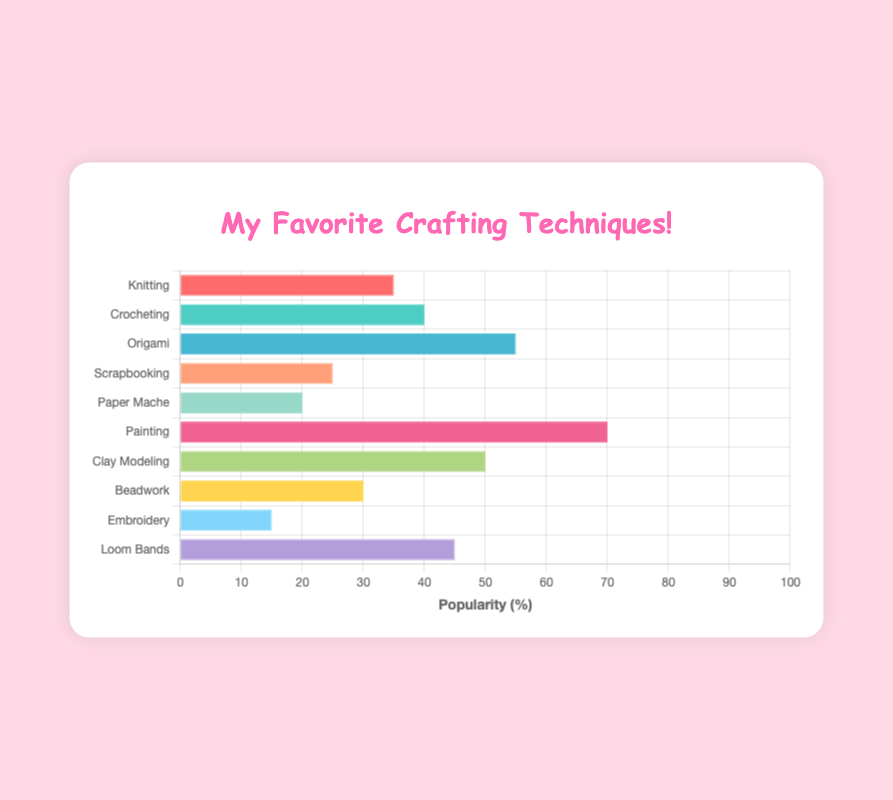Which crafting technique is the most popular among children? To determine the most popular crafting technique, we look for the bar with the highest length. The bar representing "Painting" has the highest value at 70%.
Answer: Painting Which two crafting techniques have equal popularity percentages? We need to find two bars that have the same length. In this case, no two bars have the same exact length, so there are no techniques with equal popularity.
Answer: None What is the difference in popularity between "Origami" and "Beadwork"? First, find the percentages for "Origami" and "Beadwork". Origami is 55%, and Beadwork is 30%. The difference is 55% - 30% = 25%.
Answer: 25% Which crafting technique is less popular, "Knitting" or "Clay Modeling"? Compare the lengths of the bars for "Knitting" and "Clay Modeling". Knitting has 35%, and Clay Modeling has 50%. Since 35% is less than 50%, Knitting is less popular.
Answer: Knitting Arrange the crafting techniques in descending order of popularity. Sort the percentages from highest to lowest: Painting (70%), Origami (55%), Clay Modeling (50%), Loom Bands (45%), Crocheting (40%), Knitting (35%), Beadwork (30%), Scrapbooking (25%), Paper Mache (20%), Embroidery (15%).
Answer: Painting, Origami, Clay Modeling, Loom Bands, Crocheting, Knitting, Beadwork, Scrapbooking, Paper Mache, Embroidery What is the average popularity percentage of the listed crafting techniques? Add all the percentages together: 35 + 40 + 55 + 25 + 20 + 70 + 50 + 30 + 15 + 45 = 385. Then, divide by the number of techniques, which is 10. The average is 385 / 10 = 38.5%.
Answer: 38.5% If "Painting" was removed from the chart, what would be the new maximum popularity percentage and which technique would it belong to? Without "Painting", the highest value is 55%, which corresponds to "Origami".
Answer: 55%, Origami How many techniques are more popular than "Beadwork"? First, find the percentage for Beadwork, which is 30%. Then, count the techniques with a higher percentage: Painting (70%), Origami (55%), Clay Modeling (50%), Loom Bands (45%), and Crocheting (40%). There are 5 techniques.
Answer: 5 What is the total popularity percentage of "Knitting", "Crocheting", and "Scrapbooking" combined? Add the percentages for Knitting (35%), Crocheting (40%), and Scrapbooking (25%). The total is 35 + 40 + 25 = 100%.
Answer: 100% Which techniques have a popularity percentage less than 30%? Identify the techniques with lengths representing less than 30%. These are Scrapbooking (25%), Paper Mache (20%), and Embroidery (15%).
Answer: Scrapbooking, Paper Mache, Embroidery 